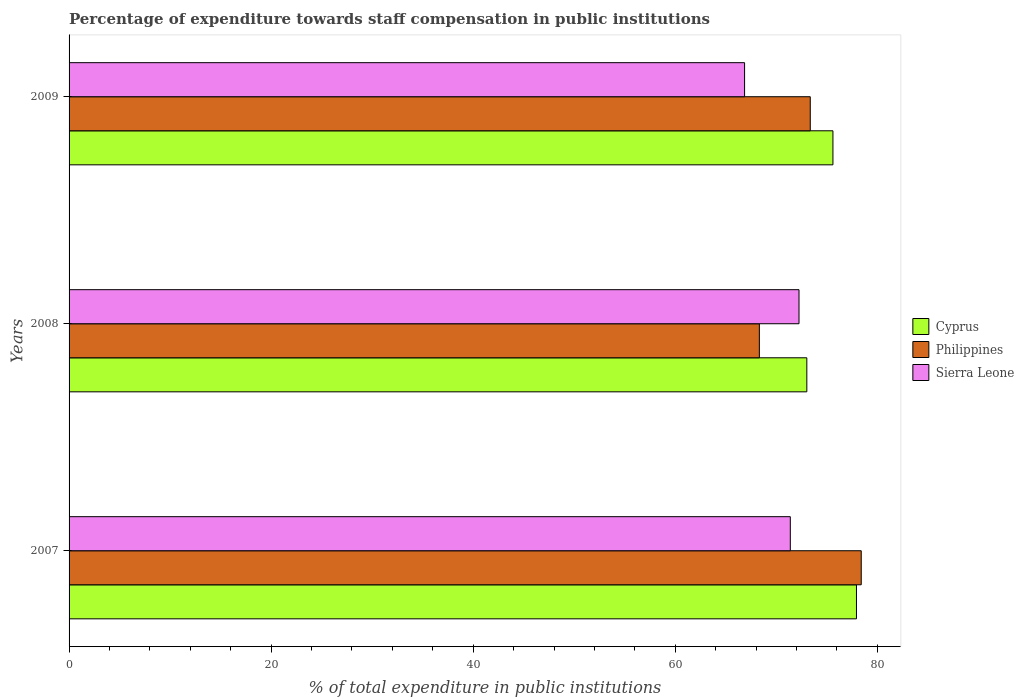How many bars are there on the 2nd tick from the top?
Your response must be concise. 3. What is the label of the 2nd group of bars from the top?
Make the answer very short. 2008. What is the percentage of expenditure towards staff compensation in Philippines in 2007?
Ensure brevity in your answer.  78.41. Across all years, what is the maximum percentage of expenditure towards staff compensation in Cyprus?
Offer a terse response. 77.94. Across all years, what is the minimum percentage of expenditure towards staff compensation in Sierra Leone?
Make the answer very short. 66.86. In which year was the percentage of expenditure towards staff compensation in Cyprus maximum?
Give a very brief answer. 2007. In which year was the percentage of expenditure towards staff compensation in Philippines minimum?
Offer a very short reply. 2008. What is the total percentage of expenditure towards staff compensation in Cyprus in the graph?
Ensure brevity in your answer.  226.58. What is the difference between the percentage of expenditure towards staff compensation in Sierra Leone in 2007 and that in 2008?
Your response must be concise. -0.86. What is the difference between the percentage of expenditure towards staff compensation in Cyprus in 2008 and the percentage of expenditure towards staff compensation in Sierra Leone in 2007?
Provide a short and direct response. 1.63. What is the average percentage of expenditure towards staff compensation in Sierra Leone per year?
Your response must be concise. 70.17. In the year 2007, what is the difference between the percentage of expenditure towards staff compensation in Cyprus and percentage of expenditure towards staff compensation in Philippines?
Offer a terse response. -0.47. What is the ratio of the percentage of expenditure towards staff compensation in Cyprus in 2007 to that in 2009?
Keep it short and to the point. 1.03. What is the difference between the highest and the second highest percentage of expenditure towards staff compensation in Philippines?
Your answer should be very brief. 5.04. What is the difference between the highest and the lowest percentage of expenditure towards staff compensation in Sierra Leone?
Provide a succinct answer. 5.39. What does the 1st bar from the top in 2007 represents?
Your response must be concise. Sierra Leone. What does the 3rd bar from the bottom in 2007 represents?
Give a very brief answer. Sierra Leone. Is it the case that in every year, the sum of the percentage of expenditure towards staff compensation in Cyprus and percentage of expenditure towards staff compensation in Philippines is greater than the percentage of expenditure towards staff compensation in Sierra Leone?
Provide a succinct answer. Yes. How many years are there in the graph?
Your answer should be very brief. 3. Does the graph contain any zero values?
Give a very brief answer. No. Does the graph contain grids?
Provide a short and direct response. No. How many legend labels are there?
Provide a short and direct response. 3. How are the legend labels stacked?
Give a very brief answer. Vertical. What is the title of the graph?
Provide a succinct answer. Percentage of expenditure towards staff compensation in public institutions. What is the label or title of the X-axis?
Offer a terse response. % of total expenditure in public institutions. What is the % of total expenditure in public institutions in Cyprus in 2007?
Keep it short and to the point. 77.94. What is the % of total expenditure in public institutions of Philippines in 2007?
Make the answer very short. 78.41. What is the % of total expenditure in public institutions in Sierra Leone in 2007?
Offer a terse response. 71.39. What is the % of total expenditure in public institutions in Cyprus in 2008?
Your answer should be compact. 73.03. What is the % of total expenditure in public institutions in Philippines in 2008?
Your answer should be very brief. 68.33. What is the % of total expenditure in public institutions of Sierra Leone in 2008?
Keep it short and to the point. 72.25. What is the % of total expenditure in public institutions of Cyprus in 2009?
Your answer should be compact. 75.61. What is the % of total expenditure in public institutions of Philippines in 2009?
Your answer should be very brief. 73.37. What is the % of total expenditure in public institutions in Sierra Leone in 2009?
Keep it short and to the point. 66.86. Across all years, what is the maximum % of total expenditure in public institutions in Cyprus?
Your answer should be compact. 77.94. Across all years, what is the maximum % of total expenditure in public institutions in Philippines?
Your answer should be very brief. 78.41. Across all years, what is the maximum % of total expenditure in public institutions of Sierra Leone?
Provide a succinct answer. 72.25. Across all years, what is the minimum % of total expenditure in public institutions in Cyprus?
Make the answer very short. 73.03. Across all years, what is the minimum % of total expenditure in public institutions of Philippines?
Ensure brevity in your answer.  68.33. Across all years, what is the minimum % of total expenditure in public institutions of Sierra Leone?
Your answer should be compact. 66.86. What is the total % of total expenditure in public institutions in Cyprus in the graph?
Provide a succinct answer. 226.58. What is the total % of total expenditure in public institutions of Philippines in the graph?
Offer a very short reply. 220.1. What is the total % of total expenditure in public institutions in Sierra Leone in the graph?
Make the answer very short. 210.51. What is the difference between the % of total expenditure in public institutions in Cyprus in 2007 and that in 2008?
Give a very brief answer. 4.91. What is the difference between the % of total expenditure in public institutions of Philippines in 2007 and that in 2008?
Offer a terse response. 10.08. What is the difference between the % of total expenditure in public institutions in Sierra Leone in 2007 and that in 2008?
Make the answer very short. -0.86. What is the difference between the % of total expenditure in public institutions in Cyprus in 2007 and that in 2009?
Provide a short and direct response. 2.33. What is the difference between the % of total expenditure in public institutions in Philippines in 2007 and that in 2009?
Give a very brief answer. 5.04. What is the difference between the % of total expenditure in public institutions of Sierra Leone in 2007 and that in 2009?
Your answer should be compact. 4.53. What is the difference between the % of total expenditure in public institutions of Cyprus in 2008 and that in 2009?
Make the answer very short. -2.58. What is the difference between the % of total expenditure in public institutions in Philippines in 2008 and that in 2009?
Provide a short and direct response. -5.04. What is the difference between the % of total expenditure in public institutions of Sierra Leone in 2008 and that in 2009?
Keep it short and to the point. 5.39. What is the difference between the % of total expenditure in public institutions in Cyprus in 2007 and the % of total expenditure in public institutions in Philippines in 2008?
Offer a very short reply. 9.61. What is the difference between the % of total expenditure in public institutions of Cyprus in 2007 and the % of total expenditure in public institutions of Sierra Leone in 2008?
Ensure brevity in your answer.  5.69. What is the difference between the % of total expenditure in public institutions in Philippines in 2007 and the % of total expenditure in public institutions in Sierra Leone in 2008?
Provide a succinct answer. 6.16. What is the difference between the % of total expenditure in public institutions in Cyprus in 2007 and the % of total expenditure in public institutions in Philippines in 2009?
Provide a short and direct response. 4.57. What is the difference between the % of total expenditure in public institutions of Cyprus in 2007 and the % of total expenditure in public institutions of Sierra Leone in 2009?
Your response must be concise. 11.08. What is the difference between the % of total expenditure in public institutions of Philippines in 2007 and the % of total expenditure in public institutions of Sierra Leone in 2009?
Make the answer very short. 11.55. What is the difference between the % of total expenditure in public institutions in Cyprus in 2008 and the % of total expenditure in public institutions in Philippines in 2009?
Offer a terse response. -0.34. What is the difference between the % of total expenditure in public institutions in Cyprus in 2008 and the % of total expenditure in public institutions in Sierra Leone in 2009?
Your answer should be very brief. 6.16. What is the difference between the % of total expenditure in public institutions in Philippines in 2008 and the % of total expenditure in public institutions in Sierra Leone in 2009?
Your answer should be compact. 1.46. What is the average % of total expenditure in public institutions in Cyprus per year?
Your response must be concise. 75.53. What is the average % of total expenditure in public institutions in Philippines per year?
Your response must be concise. 73.37. What is the average % of total expenditure in public institutions in Sierra Leone per year?
Offer a very short reply. 70.17. In the year 2007, what is the difference between the % of total expenditure in public institutions of Cyprus and % of total expenditure in public institutions of Philippines?
Keep it short and to the point. -0.47. In the year 2007, what is the difference between the % of total expenditure in public institutions in Cyprus and % of total expenditure in public institutions in Sierra Leone?
Give a very brief answer. 6.55. In the year 2007, what is the difference between the % of total expenditure in public institutions in Philippines and % of total expenditure in public institutions in Sierra Leone?
Offer a terse response. 7.02. In the year 2008, what is the difference between the % of total expenditure in public institutions in Cyprus and % of total expenditure in public institutions in Philippines?
Give a very brief answer. 4.7. In the year 2008, what is the difference between the % of total expenditure in public institutions of Cyprus and % of total expenditure in public institutions of Sierra Leone?
Your answer should be compact. 0.77. In the year 2008, what is the difference between the % of total expenditure in public institutions of Philippines and % of total expenditure in public institutions of Sierra Leone?
Provide a succinct answer. -3.93. In the year 2009, what is the difference between the % of total expenditure in public institutions of Cyprus and % of total expenditure in public institutions of Philippines?
Your response must be concise. 2.24. In the year 2009, what is the difference between the % of total expenditure in public institutions of Cyprus and % of total expenditure in public institutions of Sierra Leone?
Provide a succinct answer. 8.75. In the year 2009, what is the difference between the % of total expenditure in public institutions in Philippines and % of total expenditure in public institutions in Sierra Leone?
Make the answer very short. 6.5. What is the ratio of the % of total expenditure in public institutions in Cyprus in 2007 to that in 2008?
Provide a short and direct response. 1.07. What is the ratio of the % of total expenditure in public institutions of Philippines in 2007 to that in 2008?
Give a very brief answer. 1.15. What is the ratio of the % of total expenditure in public institutions in Cyprus in 2007 to that in 2009?
Your answer should be compact. 1.03. What is the ratio of the % of total expenditure in public institutions in Philippines in 2007 to that in 2009?
Your response must be concise. 1.07. What is the ratio of the % of total expenditure in public institutions of Sierra Leone in 2007 to that in 2009?
Make the answer very short. 1.07. What is the ratio of the % of total expenditure in public institutions in Cyprus in 2008 to that in 2009?
Make the answer very short. 0.97. What is the ratio of the % of total expenditure in public institutions of Philippines in 2008 to that in 2009?
Ensure brevity in your answer.  0.93. What is the ratio of the % of total expenditure in public institutions of Sierra Leone in 2008 to that in 2009?
Give a very brief answer. 1.08. What is the difference between the highest and the second highest % of total expenditure in public institutions of Cyprus?
Give a very brief answer. 2.33. What is the difference between the highest and the second highest % of total expenditure in public institutions of Philippines?
Offer a terse response. 5.04. What is the difference between the highest and the second highest % of total expenditure in public institutions in Sierra Leone?
Offer a terse response. 0.86. What is the difference between the highest and the lowest % of total expenditure in public institutions of Cyprus?
Provide a short and direct response. 4.91. What is the difference between the highest and the lowest % of total expenditure in public institutions of Philippines?
Ensure brevity in your answer.  10.08. What is the difference between the highest and the lowest % of total expenditure in public institutions of Sierra Leone?
Your answer should be very brief. 5.39. 